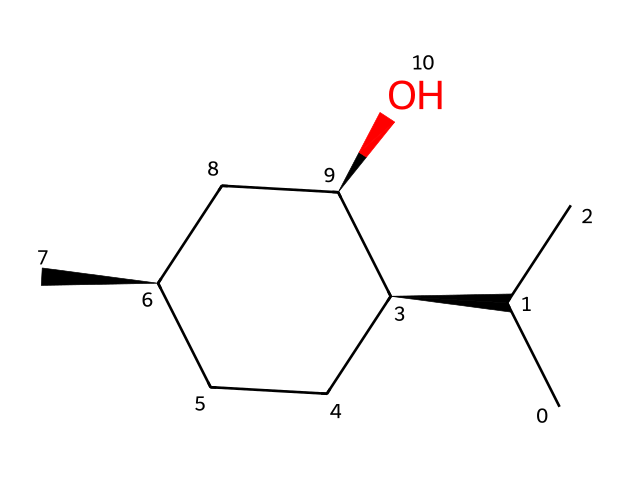How many carbon atoms are in this molecule? By examining the SMILES representation, we can count the number of "C" in the string, which represents carbon atoms. There are a total of 10 carbon atoms present.
Answer: 10 What functional group is present in this menthol structure? In the SMILES representation, there is an "O" at the end, indicating an alcohol functional group (-OH). This is characteristic of menthol.
Answer: alcohol Is this molecule a cyclic structure? The presence of the number "1" in the SMILES notation indicates the start and end of a ring. This means the molecule is indeed a cyclic compound.
Answer: yes What is the total number of hydrogen atoms in menthol? To calculate the number of hydrogen atoms, we can apply the general formula for alkanes (CnH2n+2), where n is the number of carbon atoms. For 10 carbons, it would be 22 hydrogens; however, given the presence of the alcohol group, we adjust to have 22 – 1 = 21 hydrogens.
Answer: 20 What type of chemical is menthol classified as? Menthol is classified as a cycloalkane because it contains both a cycloalkane structure and an alcohol functional group, which is typical for various terpenes and related compounds.
Answer: cycloalkane What is the stereochemistry of the menthol structure? The presence of "@" symbols in the SMILES indicates that there are chiral centers in the molecule, which means that menthol exhibits stereochemistry with specific spatial arrangements of the substituents attached to these carbon centers.
Answer: chiral 